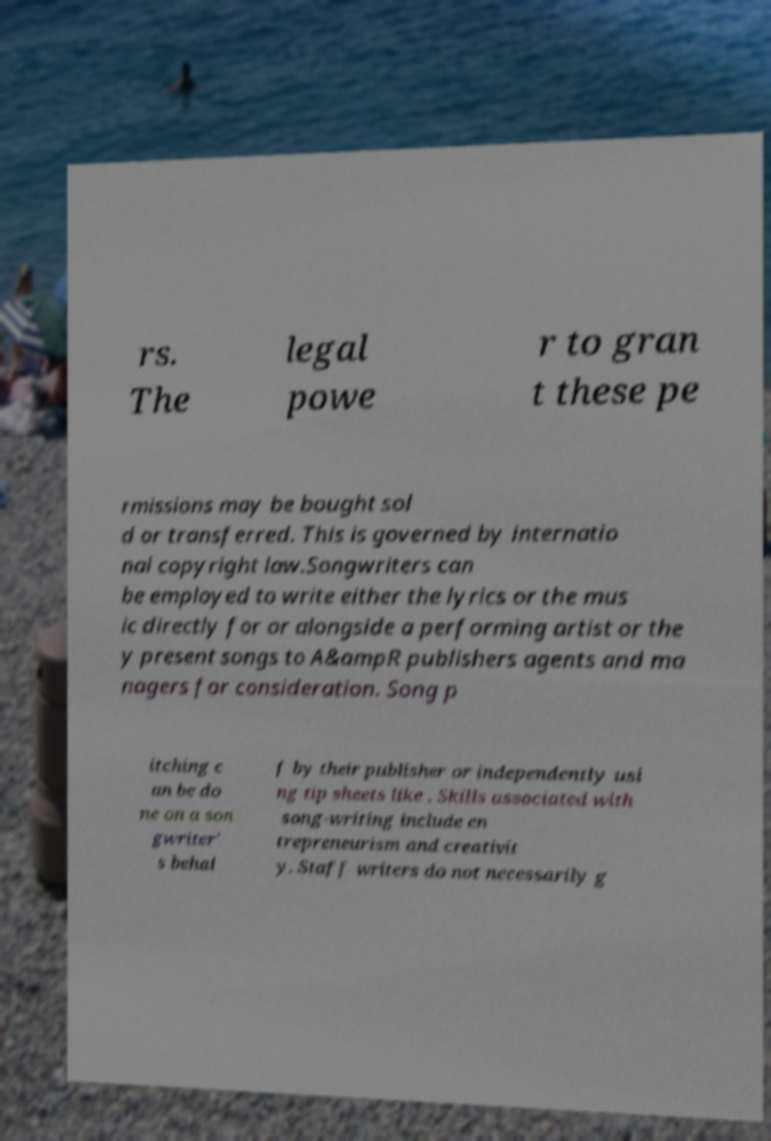Could you assist in decoding the text presented in this image and type it out clearly? rs. The legal powe r to gran t these pe rmissions may be bought sol d or transferred. This is governed by internatio nal copyright law.Songwriters can be employed to write either the lyrics or the mus ic directly for or alongside a performing artist or the y present songs to A&ampR publishers agents and ma nagers for consideration. Song p itching c an be do ne on a son gwriter' s behal f by their publisher or independently usi ng tip sheets like . Skills associated with song-writing include en trepreneurism and creativit y. Staff writers do not necessarily g 